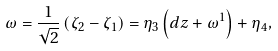Convert formula to latex. <formula><loc_0><loc_0><loc_500><loc_500>\omega = \frac { 1 } { \sqrt { 2 } } \left ( \zeta _ { 2 } - \zeta _ { 1 } \right ) = \eta _ { 3 } \left ( d z + \omega ^ { 1 } \right ) + \eta _ { 4 } ,</formula> 